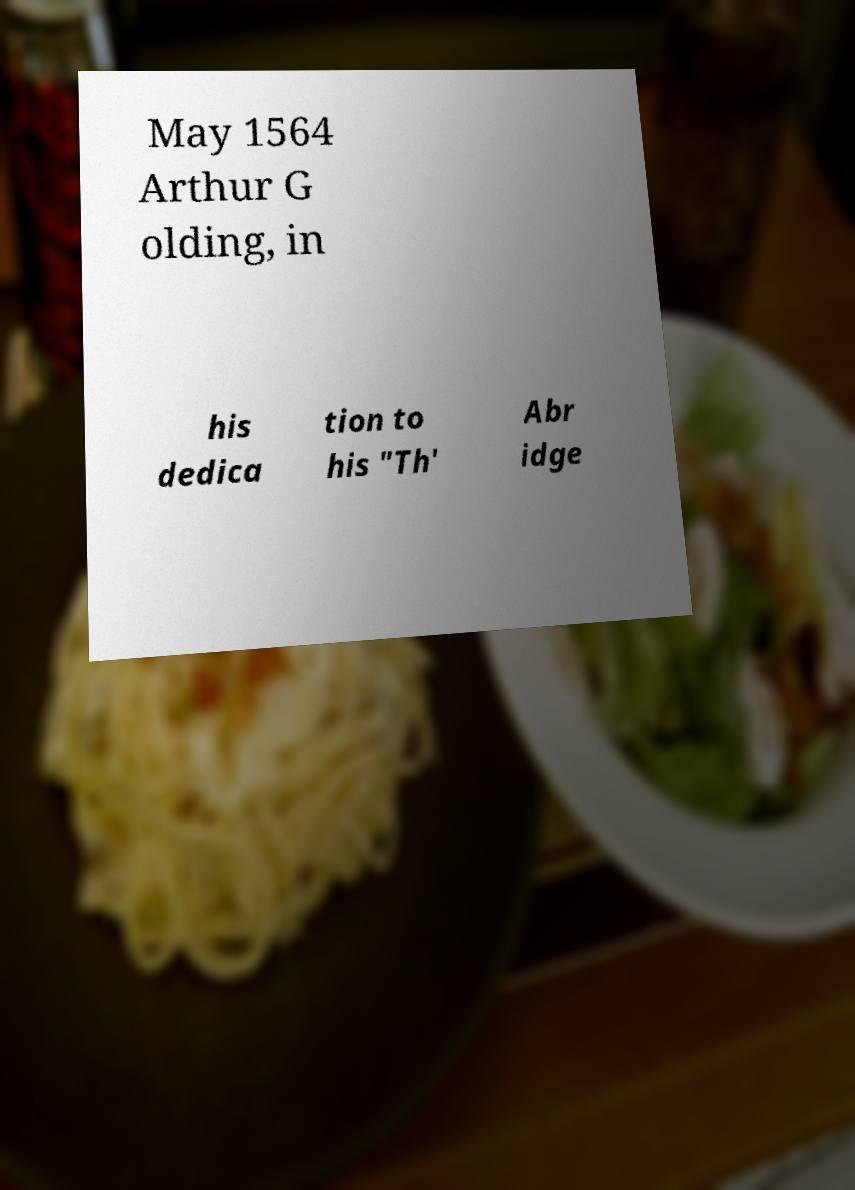Could you extract and type out the text from this image? May 1564 Arthur G olding, in his dedica tion to his "Th' Abr idge 